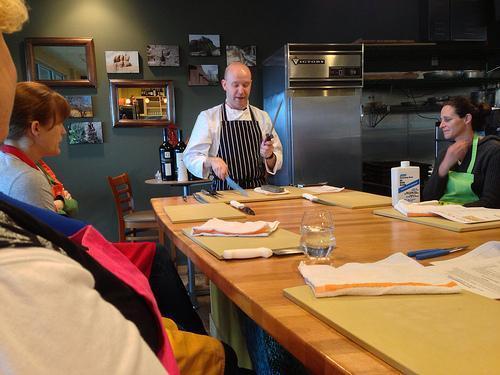How many people are there?
Give a very brief answer. 4. 